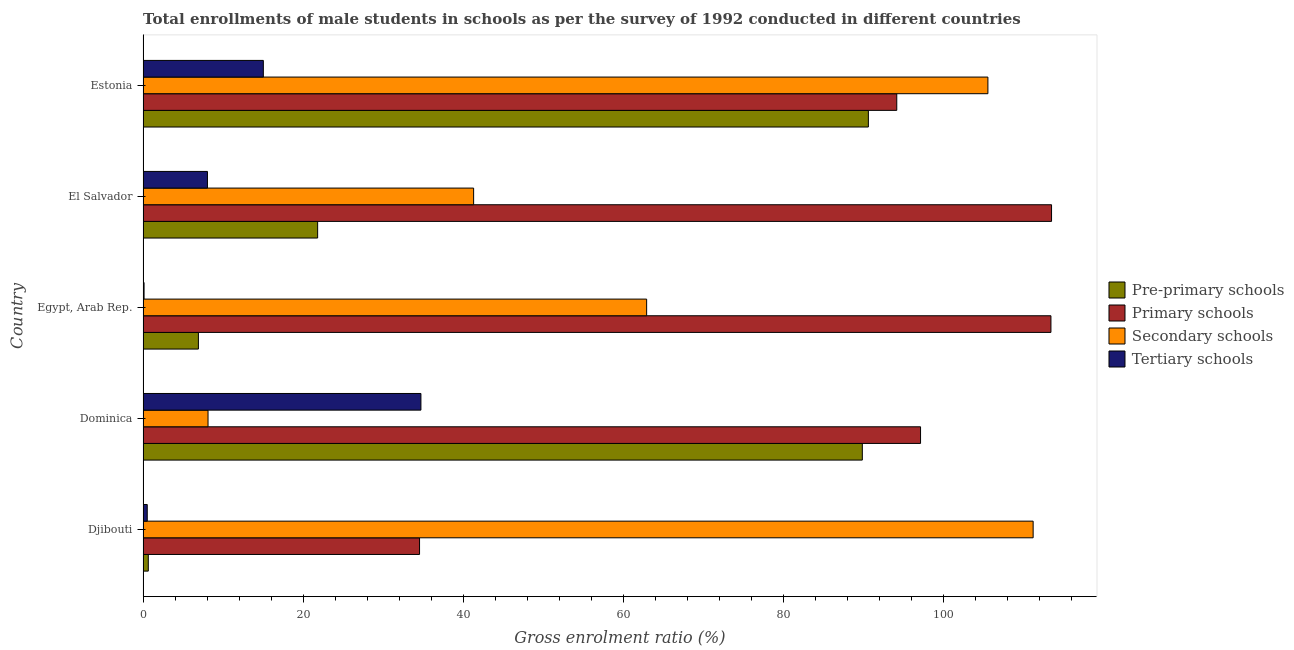How many different coloured bars are there?
Provide a short and direct response. 4. How many groups of bars are there?
Your answer should be compact. 5. Are the number of bars per tick equal to the number of legend labels?
Your response must be concise. Yes. How many bars are there on the 5th tick from the top?
Your answer should be very brief. 4. What is the label of the 3rd group of bars from the top?
Your answer should be compact. Egypt, Arab Rep. What is the gross enrolment ratio(male) in pre-primary schools in El Salvador?
Provide a succinct answer. 21.81. Across all countries, what is the maximum gross enrolment ratio(male) in secondary schools?
Give a very brief answer. 111.21. Across all countries, what is the minimum gross enrolment ratio(male) in tertiary schools?
Offer a very short reply. 0.12. In which country was the gross enrolment ratio(male) in primary schools maximum?
Your response must be concise. El Salvador. In which country was the gross enrolment ratio(male) in tertiary schools minimum?
Make the answer very short. Egypt, Arab Rep. What is the total gross enrolment ratio(male) in pre-primary schools in the graph?
Make the answer very short. 209.88. What is the difference between the gross enrolment ratio(male) in tertiary schools in Djibouti and that in Dominica?
Your response must be concise. -34.2. What is the difference between the gross enrolment ratio(male) in secondary schools in Djibouti and the gross enrolment ratio(male) in pre-primary schools in Dominica?
Provide a short and direct response. 21.34. What is the average gross enrolment ratio(male) in pre-primary schools per country?
Your answer should be very brief. 41.98. What is the difference between the gross enrolment ratio(male) in tertiary schools and gross enrolment ratio(male) in pre-primary schools in Dominica?
Provide a succinct answer. -55.15. What is the ratio of the gross enrolment ratio(male) in pre-primary schools in Djibouti to that in Dominica?
Your response must be concise. 0.01. Is the gross enrolment ratio(male) in tertiary schools in Djibouti less than that in El Salvador?
Your answer should be compact. Yes. What is the difference between the highest and the second highest gross enrolment ratio(male) in secondary schools?
Your answer should be very brief. 5.65. What is the difference between the highest and the lowest gross enrolment ratio(male) in pre-primary schools?
Your answer should be very brief. 89.97. In how many countries, is the gross enrolment ratio(male) in pre-primary schools greater than the average gross enrolment ratio(male) in pre-primary schools taken over all countries?
Offer a very short reply. 2. Is it the case that in every country, the sum of the gross enrolment ratio(male) in secondary schools and gross enrolment ratio(male) in pre-primary schools is greater than the sum of gross enrolment ratio(male) in primary schools and gross enrolment ratio(male) in tertiary schools?
Offer a terse response. Yes. What does the 2nd bar from the top in Djibouti represents?
Provide a succinct answer. Secondary schools. What does the 4th bar from the bottom in Djibouti represents?
Your answer should be compact. Tertiary schools. Is it the case that in every country, the sum of the gross enrolment ratio(male) in pre-primary schools and gross enrolment ratio(male) in primary schools is greater than the gross enrolment ratio(male) in secondary schools?
Offer a very short reply. No. How many countries are there in the graph?
Make the answer very short. 5. Does the graph contain grids?
Keep it short and to the point. No. How many legend labels are there?
Offer a very short reply. 4. How are the legend labels stacked?
Give a very brief answer. Vertical. What is the title of the graph?
Provide a short and direct response. Total enrollments of male students in schools as per the survey of 1992 conducted in different countries. What is the label or title of the Y-axis?
Ensure brevity in your answer.  Country. What is the Gross enrolment ratio (%) of Pre-primary schools in Djibouti?
Give a very brief answer. 0.65. What is the Gross enrolment ratio (%) of Primary schools in Djibouti?
Your response must be concise. 34.55. What is the Gross enrolment ratio (%) in Secondary schools in Djibouti?
Offer a terse response. 111.21. What is the Gross enrolment ratio (%) of Tertiary schools in Djibouti?
Provide a succinct answer. 0.52. What is the Gross enrolment ratio (%) of Pre-primary schools in Dominica?
Your response must be concise. 89.87. What is the Gross enrolment ratio (%) of Primary schools in Dominica?
Offer a very short reply. 97.15. What is the Gross enrolment ratio (%) of Secondary schools in Dominica?
Your answer should be compact. 8.12. What is the Gross enrolment ratio (%) of Tertiary schools in Dominica?
Ensure brevity in your answer.  34.72. What is the Gross enrolment ratio (%) of Pre-primary schools in Egypt, Arab Rep.?
Your answer should be compact. 6.91. What is the Gross enrolment ratio (%) in Primary schools in Egypt, Arab Rep.?
Your answer should be very brief. 113.44. What is the Gross enrolment ratio (%) in Secondary schools in Egypt, Arab Rep.?
Your response must be concise. 62.92. What is the Gross enrolment ratio (%) of Tertiary schools in Egypt, Arab Rep.?
Provide a succinct answer. 0.12. What is the Gross enrolment ratio (%) in Pre-primary schools in El Salvador?
Provide a short and direct response. 21.81. What is the Gross enrolment ratio (%) in Primary schools in El Salvador?
Make the answer very short. 113.51. What is the Gross enrolment ratio (%) in Secondary schools in El Salvador?
Provide a short and direct response. 41.3. What is the Gross enrolment ratio (%) of Tertiary schools in El Salvador?
Your answer should be compact. 8.04. What is the Gross enrolment ratio (%) of Pre-primary schools in Estonia?
Give a very brief answer. 90.63. What is the Gross enrolment ratio (%) of Primary schools in Estonia?
Offer a terse response. 94.17. What is the Gross enrolment ratio (%) of Secondary schools in Estonia?
Your response must be concise. 105.56. What is the Gross enrolment ratio (%) in Tertiary schools in Estonia?
Your response must be concise. 15.03. Across all countries, what is the maximum Gross enrolment ratio (%) of Pre-primary schools?
Give a very brief answer. 90.63. Across all countries, what is the maximum Gross enrolment ratio (%) of Primary schools?
Make the answer very short. 113.51. Across all countries, what is the maximum Gross enrolment ratio (%) in Secondary schools?
Offer a terse response. 111.21. Across all countries, what is the maximum Gross enrolment ratio (%) of Tertiary schools?
Your response must be concise. 34.72. Across all countries, what is the minimum Gross enrolment ratio (%) in Pre-primary schools?
Your answer should be very brief. 0.65. Across all countries, what is the minimum Gross enrolment ratio (%) of Primary schools?
Keep it short and to the point. 34.55. Across all countries, what is the minimum Gross enrolment ratio (%) of Secondary schools?
Keep it short and to the point. 8.12. Across all countries, what is the minimum Gross enrolment ratio (%) in Tertiary schools?
Your answer should be very brief. 0.12. What is the total Gross enrolment ratio (%) of Pre-primary schools in the graph?
Provide a short and direct response. 209.88. What is the total Gross enrolment ratio (%) of Primary schools in the graph?
Provide a succinct answer. 452.82. What is the total Gross enrolment ratio (%) of Secondary schools in the graph?
Your answer should be compact. 329.12. What is the total Gross enrolment ratio (%) of Tertiary schools in the graph?
Give a very brief answer. 58.44. What is the difference between the Gross enrolment ratio (%) of Pre-primary schools in Djibouti and that in Dominica?
Offer a very short reply. -89.22. What is the difference between the Gross enrolment ratio (%) of Primary schools in Djibouti and that in Dominica?
Your answer should be very brief. -62.6. What is the difference between the Gross enrolment ratio (%) of Secondary schools in Djibouti and that in Dominica?
Your response must be concise. 103.1. What is the difference between the Gross enrolment ratio (%) in Tertiary schools in Djibouti and that in Dominica?
Keep it short and to the point. -34.2. What is the difference between the Gross enrolment ratio (%) in Pre-primary schools in Djibouti and that in Egypt, Arab Rep.?
Offer a very short reply. -6.26. What is the difference between the Gross enrolment ratio (%) in Primary schools in Djibouti and that in Egypt, Arab Rep.?
Make the answer very short. -78.89. What is the difference between the Gross enrolment ratio (%) of Secondary schools in Djibouti and that in Egypt, Arab Rep.?
Your answer should be very brief. 48.29. What is the difference between the Gross enrolment ratio (%) in Tertiary schools in Djibouti and that in Egypt, Arab Rep.?
Your answer should be very brief. 0.4. What is the difference between the Gross enrolment ratio (%) of Pre-primary schools in Djibouti and that in El Salvador?
Keep it short and to the point. -21.16. What is the difference between the Gross enrolment ratio (%) of Primary schools in Djibouti and that in El Salvador?
Provide a succinct answer. -78.97. What is the difference between the Gross enrolment ratio (%) in Secondary schools in Djibouti and that in El Salvador?
Your answer should be very brief. 69.91. What is the difference between the Gross enrolment ratio (%) of Tertiary schools in Djibouti and that in El Salvador?
Offer a terse response. -7.52. What is the difference between the Gross enrolment ratio (%) of Pre-primary schools in Djibouti and that in Estonia?
Your answer should be very brief. -89.97. What is the difference between the Gross enrolment ratio (%) of Primary schools in Djibouti and that in Estonia?
Keep it short and to the point. -59.63. What is the difference between the Gross enrolment ratio (%) of Secondary schools in Djibouti and that in Estonia?
Provide a succinct answer. 5.65. What is the difference between the Gross enrolment ratio (%) of Tertiary schools in Djibouti and that in Estonia?
Give a very brief answer. -14.51. What is the difference between the Gross enrolment ratio (%) in Pre-primary schools in Dominica and that in Egypt, Arab Rep.?
Ensure brevity in your answer.  82.96. What is the difference between the Gross enrolment ratio (%) in Primary schools in Dominica and that in Egypt, Arab Rep.?
Provide a short and direct response. -16.29. What is the difference between the Gross enrolment ratio (%) in Secondary schools in Dominica and that in Egypt, Arab Rep.?
Your answer should be very brief. -54.8. What is the difference between the Gross enrolment ratio (%) of Tertiary schools in Dominica and that in Egypt, Arab Rep.?
Your answer should be compact. 34.59. What is the difference between the Gross enrolment ratio (%) of Pre-primary schools in Dominica and that in El Salvador?
Ensure brevity in your answer.  68.06. What is the difference between the Gross enrolment ratio (%) of Primary schools in Dominica and that in El Salvador?
Your answer should be compact. -16.37. What is the difference between the Gross enrolment ratio (%) of Secondary schools in Dominica and that in El Salvador?
Your answer should be compact. -33.19. What is the difference between the Gross enrolment ratio (%) of Tertiary schools in Dominica and that in El Salvador?
Provide a succinct answer. 26.67. What is the difference between the Gross enrolment ratio (%) in Pre-primary schools in Dominica and that in Estonia?
Ensure brevity in your answer.  -0.76. What is the difference between the Gross enrolment ratio (%) of Primary schools in Dominica and that in Estonia?
Provide a short and direct response. 2.97. What is the difference between the Gross enrolment ratio (%) in Secondary schools in Dominica and that in Estonia?
Your answer should be very brief. -97.44. What is the difference between the Gross enrolment ratio (%) in Tertiary schools in Dominica and that in Estonia?
Keep it short and to the point. 19.69. What is the difference between the Gross enrolment ratio (%) in Pre-primary schools in Egypt, Arab Rep. and that in El Salvador?
Give a very brief answer. -14.9. What is the difference between the Gross enrolment ratio (%) of Primary schools in Egypt, Arab Rep. and that in El Salvador?
Offer a terse response. -0.08. What is the difference between the Gross enrolment ratio (%) in Secondary schools in Egypt, Arab Rep. and that in El Salvador?
Offer a terse response. 21.62. What is the difference between the Gross enrolment ratio (%) in Tertiary schools in Egypt, Arab Rep. and that in El Salvador?
Your response must be concise. -7.92. What is the difference between the Gross enrolment ratio (%) in Pre-primary schools in Egypt, Arab Rep. and that in Estonia?
Your response must be concise. -83.71. What is the difference between the Gross enrolment ratio (%) of Primary schools in Egypt, Arab Rep. and that in Estonia?
Your response must be concise. 19.26. What is the difference between the Gross enrolment ratio (%) of Secondary schools in Egypt, Arab Rep. and that in Estonia?
Give a very brief answer. -42.64. What is the difference between the Gross enrolment ratio (%) in Tertiary schools in Egypt, Arab Rep. and that in Estonia?
Your answer should be compact. -14.9. What is the difference between the Gross enrolment ratio (%) in Pre-primary schools in El Salvador and that in Estonia?
Make the answer very short. -68.81. What is the difference between the Gross enrolment ratio (%) in Primary schools in El Salvador and that in Estonia?
Offer a very short reply. 19.34. What is the difference between the Gross enrolment ratio (%) of Secondary schools in El Salvador and that in Estonia?
Give a very brief answer. -64.26. What is the difference between the Gross enrolment ratio (%) in Tertiary schools in El Salvador and that in Estonia?
Your answer should be very brief. -6.98. What is the difference between the Gross enrolment ratio (%) of Pre-primary schools in Djibouti and the Gross enrolment ratio (%) of Primary schools in Dominica?
Ensure brevity in your answer.  -96.49. What is the difference between the Gross enrolment ratio (%) in Pre-primary schools in Djibouti and the Gross enrolment ratio (%) in Secondary schools in Dominica?
Your answer should be very brief. -7.46. What is the difference between the Gross enrolment ratio (%) of Pre-primary schools in Djibouti and the Gross enrolment ratio (%) of Tertiary schools in Dominica?
Your answer should be compact. -34.06. What is the difference between the Gross enrolment ratio (%) in Primary schools in Djibouti and the Gross enrolment ratio (%) in Secondary schools in Dominica?
Offer a very short reply. 26.43. What is the difference between the Gross enrolment ratio (%) of Primary schools in Djibouti and the Gross enrolment ratio (%) of Tertiary schools in Dominica?
Your answer should be compact. -0.17. What is the difference between the Gross enrolment ratio (%) in Secondary schools in Djibouti and the Gross enrolment ratio (%) in Tertiary schools in Dominica?
Your answer should be compact. 76.5. What is the difference between the Gross enrolment ratio (%) of Pre-primary schools in Djibouti and the Gross enrolment ratio (%) of Primary schools in Egypt, Arab Rep.?
Keep it short and to the point. -112.78. What is the difference between the Gross enrolment ratio (%) of Pre-primary schools in Djibouti and the Gross enrolment ratio (%) of Secondary schools in Egypt, Arab Rep.?
Offer a terse response. -62.27. What is the difference between the Gross enrolment ratio (%) of Pre-primary schools in Djibouti and the Gross enrolment ratio (%) of Tertiary schools in Egypt, Arab Rep.?
Give a very brief answer. 0.53. What is the difference between the Gross enrolment ratio (%) of Primary schools in Djibouti and the Gross enrolment ratio (%) of Secondary schools in Egypt, Arab Rep.?
Your answer should be very brief. -28.37. What is the difference between the Gross enrolment ratio (%) of Primary schools in Djibouti and the Gross enrolment ratio (%) of Tertiary schools in Egypt, Arab Rep.?
Your answer should be compact. 34.42. What is the difference between the Gross enrolment ratio (%) in Secondary schools in Djibouti and the Gross enrolment ratio (%) in Tertiary schools in Egypt, Arab Rep.?
Make the answer very short. 111.09. What is the difference between the Gross enrolment ratio (%) of Pre-primary schools in Djibouti and the Gross enrolment ratio (%) of Primary schools in El Salvador?
Provide a short and direct response. -112.86. What is the difference between the Gross enrolment ratio (%) in Pre-primary schools in Djibouti and the Gross enrolment ratio (%) in Secondary schools in El Salvador?
Offer a terse response. -40.65. What is the difference between the Gross enrolment ratio (%) of Pre-primary schools in Djibouti and the Gross enrolment ratio (%) of Tertiary schools in El Salvador?
Ensure brevity in your answer.  -7.39. What is the difference between the Gross enrolment ratio (%) in Primary schools in Djibouti and the Gross enrolment ratio (%) in Secondary schools in El Salvador?
Your response must be concise. -6.76. What is the difference between the Gross enrolment ratio (%) of Primary schools in Djibouti and the Gross enrolment ratio (%) of Tertiary schools in El Salvador?
Keep it short and to the point. 26.5. What is the difference between the Gross enrolment ratio (%) in Secondary schools in Djibouti and the Gross enrolment ratio (%) in Tertiary schools in El Salvador?
Make the answer very short. 103.17. What is the difference between the Gross enrolment ratio (%) in Pre-primary schools in Djibouti and the Gross enrolment ratio (%) in Primary schools in Estonia?
Your response must be concise. -93.52. What is the difference between the Gross enrolment ratio (%) in Pre-primary schools in Djibouti and the Gross enrolment ratio (%) in Secondary schools in Estonia?
Your response must be concise. -104.91. What is the difference between the Gross enrolment ratio (%) of Pre-primary schools in Djibouti and the Gross enrolment ratio (%) of Tertiary schools in Estonia?
Your answer should be very brief. -14.37. What is the difference between the Gross enrolment ratio (%) of Primary schools in Djibouti and the Gross enrolment ratio (%) of Secondary schools in Estonia?
Offer a very short reply. -71.02. What is the difference between the Gross enrolment ratio (%) in Primary schools in Djibouti and the Gross enrolment ratio (%) in Tertiary schools in Estonia?
Your response must be concise. 19.52. What is the difference between the Gross enrolment ratio (%) of Secondary schools in Djibouti and the Gross enrolment ratio (%) of Tertiary schools in Estonia?
Your response must be concise. 96.19. What is the difference between the Gross enrolment ratio (%) in Pre-primary schools in Dominica and the Gross enrolment ratio (%) in Primary schools in Egypt, Arab Rep.?
Offer a terse response. -23.57. What is the difference between the Gross enrolment ratio (%) in Pre-primary schools in Dominica and the Gross enrolment ratio (%) in Secondary schools in Egypt, Arab Rep.?
Ensure brevity in your answer.  26.95. What is the difference between the Gross enrolment ratio (%) of Pre-primary schools in Dominica and the Gross enrolment ratio (%) of Tertiary schools in Egypt, Arab Rep.?
Your answer should be compact. 89.75. What is the difference between the Gross enrolment ratio (%) of Primary schools in Dominica and the Gross enrolment ratio (%) of Secondary schools in Egypt, Arab Rep.?
Give a very brief answer. 34.23. What is the difference between the Gross enrolment ratio (%) of Primary schools in Dominica and the Gross enrolment ratio (%) of Tertiary schools in Egypt, Arab Rep.?
Provide a succinct answer. 97.02. What is the difference between the Gross enrolment ratio (%) of Secondary schools in Dominica and the Gross enrolment ratio (%) of Tertiary schools in Egypt, Arab Rep.?
Your response must be concise. 7.99. What is the difference between the Gross enrolment ratio (%) in Pre-primary schools in Dominica and the Gross enrolment ratio (%) in Primary schools in El Salvador?
Give a very brief answer. -23.64. What is the difference between the Gross enrolment ratio (%) of Pre-primary schools in Dominica and the Gross enrolment ratio (%) of Secondary schools in El Salvador?
Give a very brief answer. 48.57. What is the difference between the Gross enrolment ratio (%) in Pre-primary schools in Dominica and the Gross enrolment ratio (%) in Tertiary schools in El Salvador?
Provide a succinct answer. 81.83. What is the difference between the Gross enrolment ratio (%) of Primary schools in Dominica and the Gross enrolment ratio (%) of Secondary schools in El Salvador?
Give a very brief answer. 55.84. What is the difference between the Gross enrolment ratio (%) in Primary schools in Dominica and the Gross enrolment ratio (%) in Tertiary schools in El Salvador?
Provide a short and direct response. 89.1. What is the difference between the Gross enrolment ratio (%) of Secondary schools in Dominica and the Gross enrolment ratio (%) of Tertiary schools in El Salvador?
Ensure brevity in your answer.  0.07. What is the difference between the Gross enrolment ratio (%) in Pre-primary schools in Dominica and the Gross enrolment ratio (%) in Primary schools in Estonia?
Ensure brevity in your answer.  -4.3. What is the difference between the Gross enrolment ratio (%) in Pre-primary schools in Dominica and the Gross enrolment ratio (%) in Secondary schools in Estonia?
Your answer should be very brief. -15.69. What is the difference between the Gross enrolment ratio (%) of Pre-primary schools in Dominica and the Gross enrolment ratio (%) of Tertiary schools in Estonia?
Offer a terse response. 74.84. What is the difference between the Gross enrolment ratio (%) of Primary schools in Dominica and the Gross enrolment ratio (%) of Secondary schools in Estonia?
Provide a short and direct response. -8.42. What is the difference between the Gross enrolment ratio (%) of Primary schools in Dominica and the Gross enrolment ratio (%) of Tertiary schools in Estonia?
Offer a very short reply. 82.12. What is the difference between the Gross enrolment ratio (%) in Secondary schools in Dominica and the Gross enrolment ratio (%) in Tertiary schools in Estonia?
Offer a very short reply. -6.91. What is the difference between the Gross enrolment ratio (%) in Pre-primary schools in Egypt, Arab Rep. and the Gross enrolment ratio (%) in Primary schools in El Salvador?
Offer a very short reply. -106.6. What is the difference between the Gross enrolment ratio (%) of Pre-primary schools in Egypt, Arab Rep. and the Gross enrolment ratio (%) of Secondary schools in El Salvador?
Your answer should be very brief. -34.39. What is the difference between the Gross enrolment ratio (%) in Pre-primary schools in Egypt, Arab Rep. and the Gross enrolment ratio (%) in Tertiary schools in El Salvador?
Provide a succinct answer. -1.13. What is the difference between the Gross enrolment ratio (%) in Primary schools in Egypt, Arab Rep. and the Gross enrolment ratio (%) in Secondary schools in El Salvador?
Provide a short and direct response. 72.13. What is the difference between the Gross enrolment ratio (%) of Primary schools in Egypt, Arab Rep. and the Gross enrolment ratio (%) of Tertiary schools in El Salvador?
Offer a terse response. 105.39. What is the difference between the Gross enrolment ratio (%) of Secondary schools in Egypt, Arab Rep. and the Gross enrolment ratio (%) of Tertiary schools in El Salvador?
Your response must be concise. 54.88. What is the difference between the Gross enrolment ratio (%) of Pre-primary schools in Egypt, Arab Rep. and the Gross enrolment ratio (%) of Primary schools in Estonia?
Give a very brief answer. -87.26. What is the difference between the Gross enrolment ratio (%) in Pre-primary schools in Egypt, Arab Rep. and the Gross enrolment ratio (%) in Secondary schools in Estonia?
Offer a very short reply. -98.65. What is the difference between the Gross enrolment ratio (%) in Pre-primary schools in Egypt, Arab Rep. and the Gross enrolment ratio (%) in Tertiary schools in Estonia?
Ensure brevity in your answer.  -8.11. What is the difference between the Gross enrolment ratio (%) of Primary schools in Egypt, Arab Rep. and the Gross enrolment ratio (%) of Secondary schools in Estonia?
Keep it short and to the point. 7.87. What is the difference between the Gross enrolment ratio (%) of Primary schools in Egypt, Arab Rep. and the Gross enrolment ratio (%) of Tertiary schools in Estonia?
Keep it short and to the point. 98.41. What is the difference between the Gross enrolment ratio (%) of Secondary schools in Egypt, Arab Rep. and the Gross enrolment ratio (%) of Tertiary schools in Estonia?
Your answer should be very brief. 47.89. What is the difference between the Gross enrolment ratio (%) in Pre-primary schools in El Salvador and the Gross enrolment ratio (%) in Primary schools in Estonia?
Your answer should be very brief. -72.36. What is the difference between the Gross enrolment ratio (%) of Pre-primary schools in El Salvador and the Gross enrolment ratio (%) of Secondary schools in Estonia?
Your answer should be very brief. -83.75. What is the difference between the Gross enrolment ratio (%) of Pre-primary schools in El Salvador and the Gross enrolment ratio (%) of Tertiary schools in Estonia?
Provide a short and direct response. 6.79. What is the difference between the Gross enrolment ratio (%) of Primary schools in El Salvador and the Gross enrolment ratio (%) of Secondary schools in Estonia?
Provide a succinct answer. 7.95. What is the difference between the Gross enrolment ratio (%) of Primary schools in El Salvador and the Gross enrolment ratio (%) of Tertiary schools in Estonia?
Make the answer very short. 98.49. What is the difference between the Gross enrolment ratio (%) of Secondary schools in El Salvador and the Gross enrolment ratio (%) of Tertiary schools in Estonia?
Keep it short and to the point. 26.28. What is the average Gross enrolment ratio (%) in Pre-primary schools per country?
Provide a short and direct response. 41.98. What is the average Gross enrolment ratio (%) in Primary schools per country?
Ensure brevity in your answer.  90.56. What is the average Gross enrolment ratio (%) in Secondary schools per country?
Keep it short and to the point. 65.82. What is the average Gross enrolment ratio (%) of Tertiary schools per country?
Your response must be concise. 11.69. What is the difference between the Gross enrolment ratio (%) in Pre-primary schools and Gross enrolment ratio (%) in Primary schools in Djibouti?
Keep it short and to the point. -33.89. What is the difference between the Gross enrolment ratio (%) in Pre-primary schools and Gross enrolment ratio (%) in Secondary schools in Djibouti?
Make the answer very short. -110.56. What is the difference between the Gross enrolment ratio (%) of Pre-primary schools and Gross enrolment ratio (%) of Tertiary schools in Djibouti?
Your answer should be very brief. 0.13. What is the difference between the Gross enrolment ratio (%) in Primary schools and Gross enrolment ratio (%) in Secondary schools in Djibouti?
Your answer should be very brief. -76.67. What is the difference between the Gross enrolment ratio (%) in Primary schools and Gross enrolment ratio (%) in Tertiary schools in Djibouti?
Make the answer very short. 34.02. What is the difference between the Gross enrolment ratio (%) of Secondary schools and Gross enrolment ratio (%) of Tertiary schools in Djibouti?
Your response must be concise. 110.69. What is the difference between the Gross enrolment ratio (%) in Pre-primary schools and Gross enrolment ratio (%) in Primary schools in Dominica?
Offer a terse response. -7.28. What is the difference between the Gross enrolment ratio (%) in Pre-primary schools and Gross enrolment ratio (%) in Secondary schools in Dominica?
Your answer should be very brief. 81.75. What is the difference between the Gross enrolment ratio (%) in Pre-primary schools and Gross enrolment ratio (%) in Tertiary schools in Dominica?
Your answer should be compact. 55.15. What is the difference between the Gross enrolment ratio (%) in Primary schools and Gross enrolment ratio (%) in Secondary schools in Dominica?
Your response must be concise. 89.03. What is the difference between the Gross enrolment ratio (%) of Primary schools and Gross enrolment ratio (%) of Tertiary schools in Dominica?
Provide a succinct answer. 62.43. What is the difference between the Gross enrolment ratio (%) of Secondary schools and Gross enrolment ratio (%) of Tertiary schools in Dominica?
Your answer should be very brief. -26.6. What is the difference between the Gross enrolment ratio (%) of Pre-primary schools and Gross enrolment ratio (%) of Primary schools in Egypt, Arab Rep.?
Your answer should be very brief. -106.52. What is the difference between the Gross enrolment ratio (%) of Pre-primary schools and Gross enrolment ratio (%) of Secondary schools in Egypt, Arab Rep.?
Keep it short and to the point. -56.01. What is the difference between the Gross enrolment ratio (%) of Pre-primary schools and Gross enrolment ratio (%) of Tertiary schools in Egypt, Arab Rep.?
Provide a short and direct response. 6.79. What is the difference between the Gross enrolment ratio (%) of Primary schools and Gross enrolment ratio (%) of Secondary schools in Egypt, Arab Rep.?
Ensure brevity in your answer.  50.52. What is the difference between the Gross enrolment ratio (%) of Primary schools and Gross enrolment ratio (%) of Tertiary schools in Egypt, Arab Rep.?
Give a very brief answer. 113.31. What is the difference between the Gross enrolment ratio (%) of Secondary schools and Gross enrolment ratio (%) of Tertiary schools in Egypt, Arab Rep.?
Offer a very short reply. 62.8. What is the difference between the Gross enrolment ratio (%) of Pre-primary schools and Gross enrolment ratio (%) of Primary schools in El Salvador?
Provide a short and direct response. -91.7. What is the difference between the Gross enrolment ratio (%) in Pre-primary schools and Gross enrolment ratio (%) in Secondary schools in El Salvador?
Provide a short and direct response. -19.49. What is the difference between the Gross enrolment ratio (%) in Pre-primary schools and Gross enrolment ratio (%) in Tertiary schools in El Salvador?
Provide a short and direct response. 13.77. What is the difference between the Gross enrolment ratio (%) of Primary schools and Gross enrolment ratio (%) of Secondary schools in El Salvador?
Provide a short and direct response. 72.21. What is the difference between the Gross enrolment ratio (%) in Primary schools and Gross enrolment ratio (%) in Tertiary schools in El Salvador?
Offer a very short reply. 105.47. What is the difference between the Gross enrolment ratio (%) of Secondary schools and Gross enrolment ratio (%) of Tertiary schools in El Salvador?
Ensure brevity in your answer.  33.26. What is the difference between the Gross enrolment ratio (%) in Pre-primary schools and Gross enrolment ratio (%) in Primary schools in Estonia?
Your answer should be compact. -3.55. What is the difference between the Gross enrolment ratio (%) of Pre-primary schools and Gross enrolment ratio (%) of Secondary schools in Estonia?
Provide a succinct answer. -14.94. What is the difference between the Gross enrolment ratio (%) of Pre-primary schools and Gross enrolment ratio (%) of Tertiary schools in Estonia?
Make the answer very short. 75.6. What is the difference between the Gross enrolment ratio (%) in Primary schools and Gross enrolment ratio (%) in Secondary schools in Estonia?
Ensure brevity in your answer.  -11.39. What is the difference between the Gross enrolment ratio (%) of Primary schools and Gross enrolment ratio (%) of Tertiary schools in Estonia?
Ensure brevity in your answer.  79.15. What is the difference between the Gross enrolment ratio (%) of Secondary schools and Gross enrolment ratio (%) of Tertiary schools in Estonia?
Your answer should be very brief. 90.53. What is the ratio of the Gross enrolment ratio (%) of Pre-primary schools in Djibouti to that in Dominica?
Make the answer very short. 0.01. What is the ratio of the Gross enrolment ratio (%) of Primary schools in Djibouti to that in Dominica?
Ensure brevity in your answer.  0.36. What is the ratio of the Gross enrolment ratio (%) of Secondary schools in Djibouti to that in Dominica?
Ensure brevity in your answer.  13.7. What is the ratio of the Gross enrolment ratio (%) of Tertiary schools in Djibouti to that in Dominica?
Ensure brevity in your answer.  0.02. What is the ratio of the Gross enrolment ratio (%) of Pre-primary schools in Djibouti to that in Egypt, Arab Rep.?
Ensure brevity in your answer.  0.09. What is the ratio of the Gross enrolment ratio (%) in Primary schools in Djibouti to that in Egypt, Arab Rep.?
Provide a succinct answer. 0.3. What is the ratio of the Gross enrolment ratio (%) of Secondary schools in Djibouti to that in Egypt, Arab Rep.?
Make the answer very short. 1.77. What is the ratio of the Gross enrolment ratio (%) in Tertiary schools in Djibouti to that in Egypt, Arab Rep.?
Your answer should be very brief. 4.2. What is the ratio of the Gross enrolment ratio (%) in Pre-primary schools in Djibouti to that in El Salvador?
Provide a short and direct response. 0.03. What is the ratio of the Gross enrolment ratio (%) of Primary schools in Djibouti to that in El Salvador?
Give a very brief answer. 0.3. What is the ratio of the Gross enrolment ratio (%) in Secondary schools in Djibouti to that in El Salvador?
Your answer should be very brief. 2.69. What is the ratio of the Gross enrolment ratio (%) of Tertiary schools in Djibouti to that in El Salvador?
Provide a succinct answer. 0.07. What is the ratio of the Gross enrolment ratio (%) in Pre-primary schools in Djibouti to that in Estonia?
Your answer should be very brief. 0.01. What is the ratio of the Gross enrolment ratio (%) of Primary schools in Djibouti to that in Estonia?
Give a very brief answer. 0.37. What is the ratio of the Gross enrolment ratio (%) of Secondary schools in Djibouti to that in Estonia?
Keep it short and to the point. 1.05. What is the ratio of the Gross enrolment ratio (%) of Tertiary schools in Djibouti to that in Estonia?
Provide a short and direct response. 0.03. What is the ratio of the Gross enrolment ratio (%) in Pre-primary schools in Dominica to that in Egypt, Arab Rep.?
Give a very brief answer. 13. What is the ratio of the Gross enrolment ratio (%) in Primary schools in Dominica to that in Egypt, Arab Rep.?
Offer a terse response. 0.86. What is the ratio of the Gross enrolment ratio (%) in Secondary schools in Dominica to that in Egypt, Arab Rep.?
Offer a terse response. 0.13. What is the ratio of the Gross enrolment ratio (%) of Tertiary schools in Dominica to that in Egypt, Arab Rep.?
Your answer should be compact. 278.82. What is the ratio of the Gross enrolment ratio (%) of Pre-primary schools in Dominica to that in El Salvador?
Offer a terse response. 4.12. What is the ratio of the Gross enrolment ratio (%) in Primary schools in Dominica to that in El Salvador?
Make the answer very short. 0.86. What is the ratio of the Gross enrolment ratio (%) in Secondary schools in Dominica to that in El Salvador?
Offer a terse response. 0.2. What is the ratio of the Gross enrolment ratio (%) of Tertiary schools in Dominica to that in El Salvador?
Make the answer very short. 4.32. What is the ratio of the Gross enrolment ratio (%) of Pre-primary schools in Dominica to that in Estonia?
Your answer should be compact. 0.99. What is the ratio of the Gross enrolment ratio (%) of Primary schools in Dominica to that in Estonia?
Keep it short and to the point. 1.03. What is the ratio of the Gross enrolment ratio (%) of Secondary schools in Dominica to that in Estonia?
Ensure brevity in your answer.  0.08. What is the ratio of the Gross enrolment ratio (%) in Tertiary schools in Dominica to that in Estonia?
Offer a very short reply. 2.31. What is the ratio of the Gross enrolment ratio (%) of Pre-primary schools in Egypt, Arab Rep. to that in El Salvador?
Ensure brevity in your answer.  0.32. What is the ratio of the Gross enrolment ratio (%) of Primary schools in Egypt, Arab Rep. to that in El Salvador?
Offer a very short reply. 1. What is the ratio of the Gross enrolment ratio (%) in Secondary schools in Egypt, Arab Rep. to that in El Salvador?
Make the answer very short. 1.52. What is the ratio of the Gross enrolment ratio (%) of Tertiary schools in Egypt, Arab Rep. to that in El Salvador?
Ensure brevity in your answer.  0.02. What is the ratio of the Gross enrolment ratio (%) in Pre-primary schools in Egypt, Arab Rep. to that in Estonia?
Offer a very short reply. 0.08. What is the ratio of the Gross enrolment ratio (%) of Primary schools in Egypt, Arab Rep. to that in Estonia?
Your answer should be compact. 1.2. What is the ratio of the Gross enrolment ratio (%) in Secondary schools in Egypt, Arab Rep. to that in Estonia?
Provide a succinct answer. 0.6. What is the ratio of the Gross enrolment ratio (%) of Tertiary schools in Egypt, Arab Rep. to that in Estonia?
Your answer should be compact. 0.01. What is the ratio of the Gross enrolment ratio (%) in Pre-primary schools in El Salvador to that in Estonia?
Your response must be concise. 0.24. What is the ratio of the Gross enrolment ratio (%) of Primary schools in El Salvador to that in Estonia?
Keep it short and to the point. 1.21. What is the ratio of the Gross enrolment ratio (%) in Secondary schools in El Salvador to that in Estonia?
Your answer should be compact. 0.39. What is the ratio of the Gross enrolment ratio (%) of Tertiary schools in El Salvador to that in Estonia?
Your answer should be very brief. 0.54. What is the difference between the highest and the second highest Gross enrolment ratio (%) in Pre-primary schools?
Your response must be concise. 0.76. What is the difference between the highest and the second highest Gross enrolment ratio (%) of Primary schools?
Offer a terse response. 0.08. What is the difference between the highest and the second highest Gross enrolment ratio (%) of Secondary schools?
Keep it short and to the point. 5.65. What is the difference between the highest and the second highest Gross enrolment ratio (%) of Tertiary schools?
Offer a very short reply. 19.69. What is the difference between the highest and the lowest Gross enrolment ratio (%) of Pre-primary schools?
Give a very brief answer. 89.97. What is the difference between the highest and the lowest Gross enrolment ratio (%) in Primary schools?
Offer a very short reply. 78.97. What is the difference between the highest and the lowest Gross enrolment ratio (%) in Secondary schools?
Your answer should be compact. 103.1. What is the difference between the highest and the lowest Gross enrolment ratio (%) in Tertiary schools?
Make the answer very short. 34.59. 